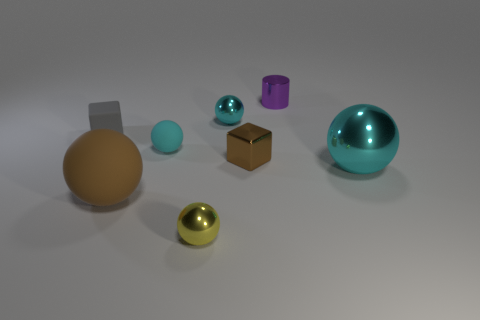What number of objects are either brown objects in front of the big cyan object or big gray cylinders?
Ensure brevity in your answer.  1. There is a brown thing that is in front of the tiny cube to the right of the small gray block; what shape is it?
Your answer should be very brief. Sphere. Does the metallic block have the same size as the cyan metallic sphere that is left of the tiny purple cylinder?
Your answer should be very brief. Yes. What material is the brown thing on the right side of the yellow metallic sphere?
Ensure brevity in your answer.  Metal. How many cyan shiny balls are to the left of the large cyan thing and in front of the tiny rubber cube?
Make the answer very short. 0. There is a brown cube that is the same size as the purple metal thing; what is it made of?
Provide a short and direct response. Metal. There is a rubber thing behind the tiny matte sphere; is it the same size as the cyan object right of the purple cylinder?
Offer a very short reply. No. Are there any big cyan metal spheres in front of the tiny cylinder?
Your answer should be compact. Yes. There is a small metallic object that is to the left of the tiny sphere that is on the right side of the yellow shiny object; what is its color?
Provide a short and direct response. Yellow. Are there fewer shiny blocks than large spheres?
Your response must be concise. Yes. 